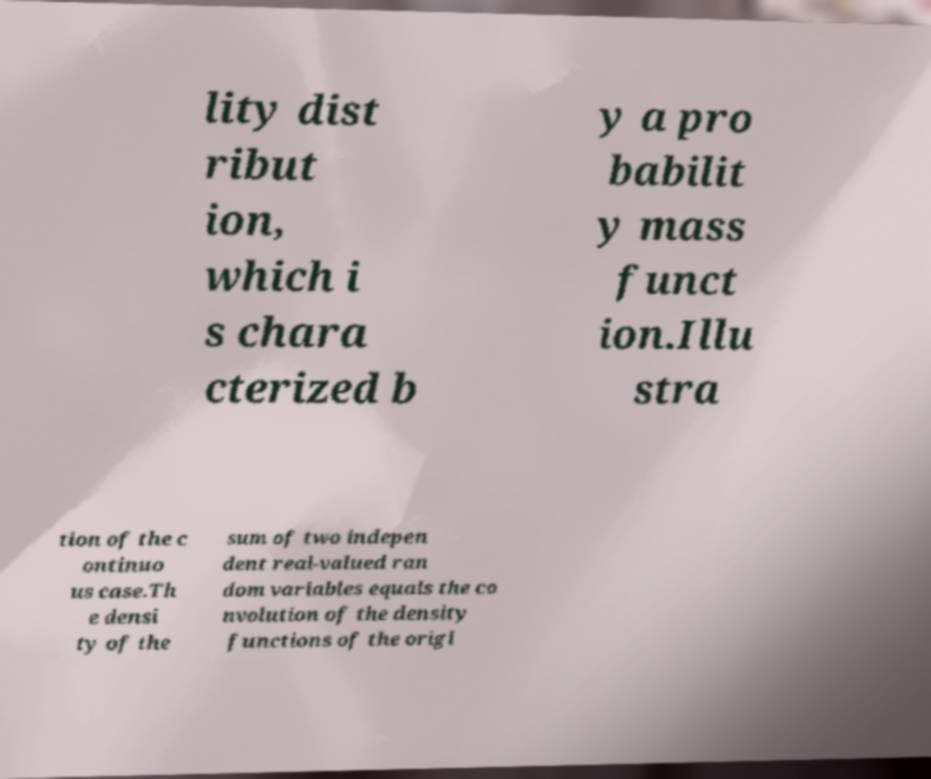Please read and relay the text visible in this image. What does it say? lity dist ribut ion, which i s chara cterized b y a pro babilit y mass funct ion.Illu stra tion of the c ontinuo us case.Th e densi ty of the sum of two indepen dent real-valued ran dom variables equals the co nvolution of the density functions of the origi 